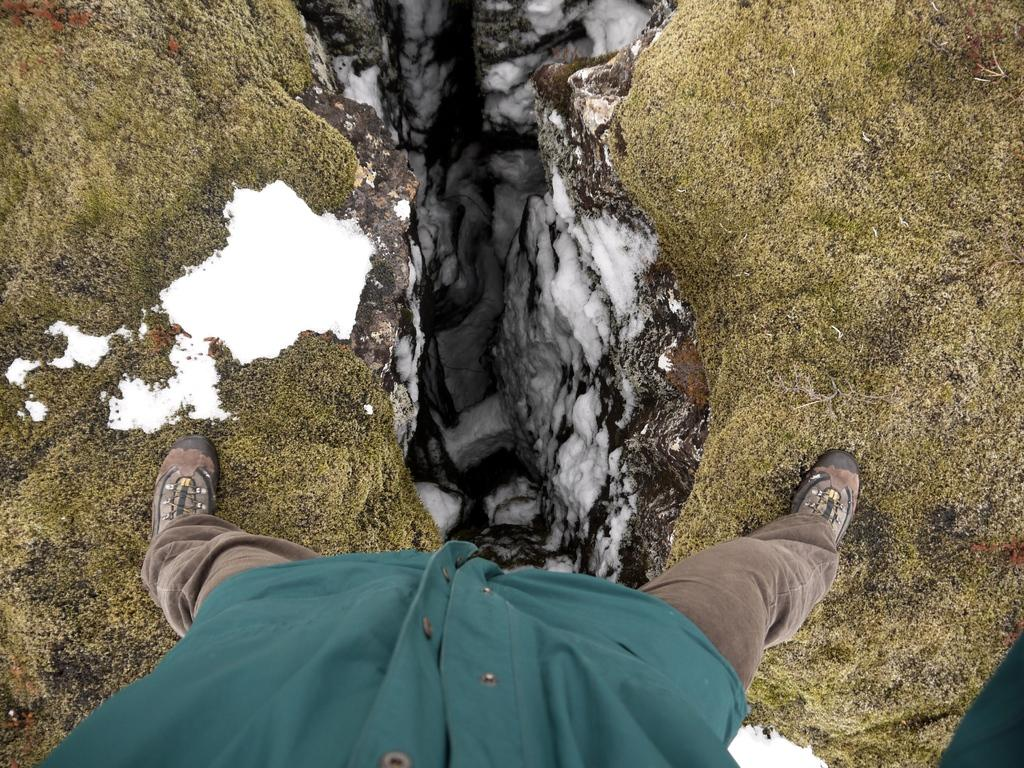What is the main subject of the image? There is a person in the image. What is the person wearing on their feet? The person is wearing shoes. Where is the person standing? The person is standing on the grass. What can be seen in the background of the image? There are rocks and snow in the background of the image. What type of boat is the farmer using to transport the army in the image? There is no boat, farmer, or army present in the image. 